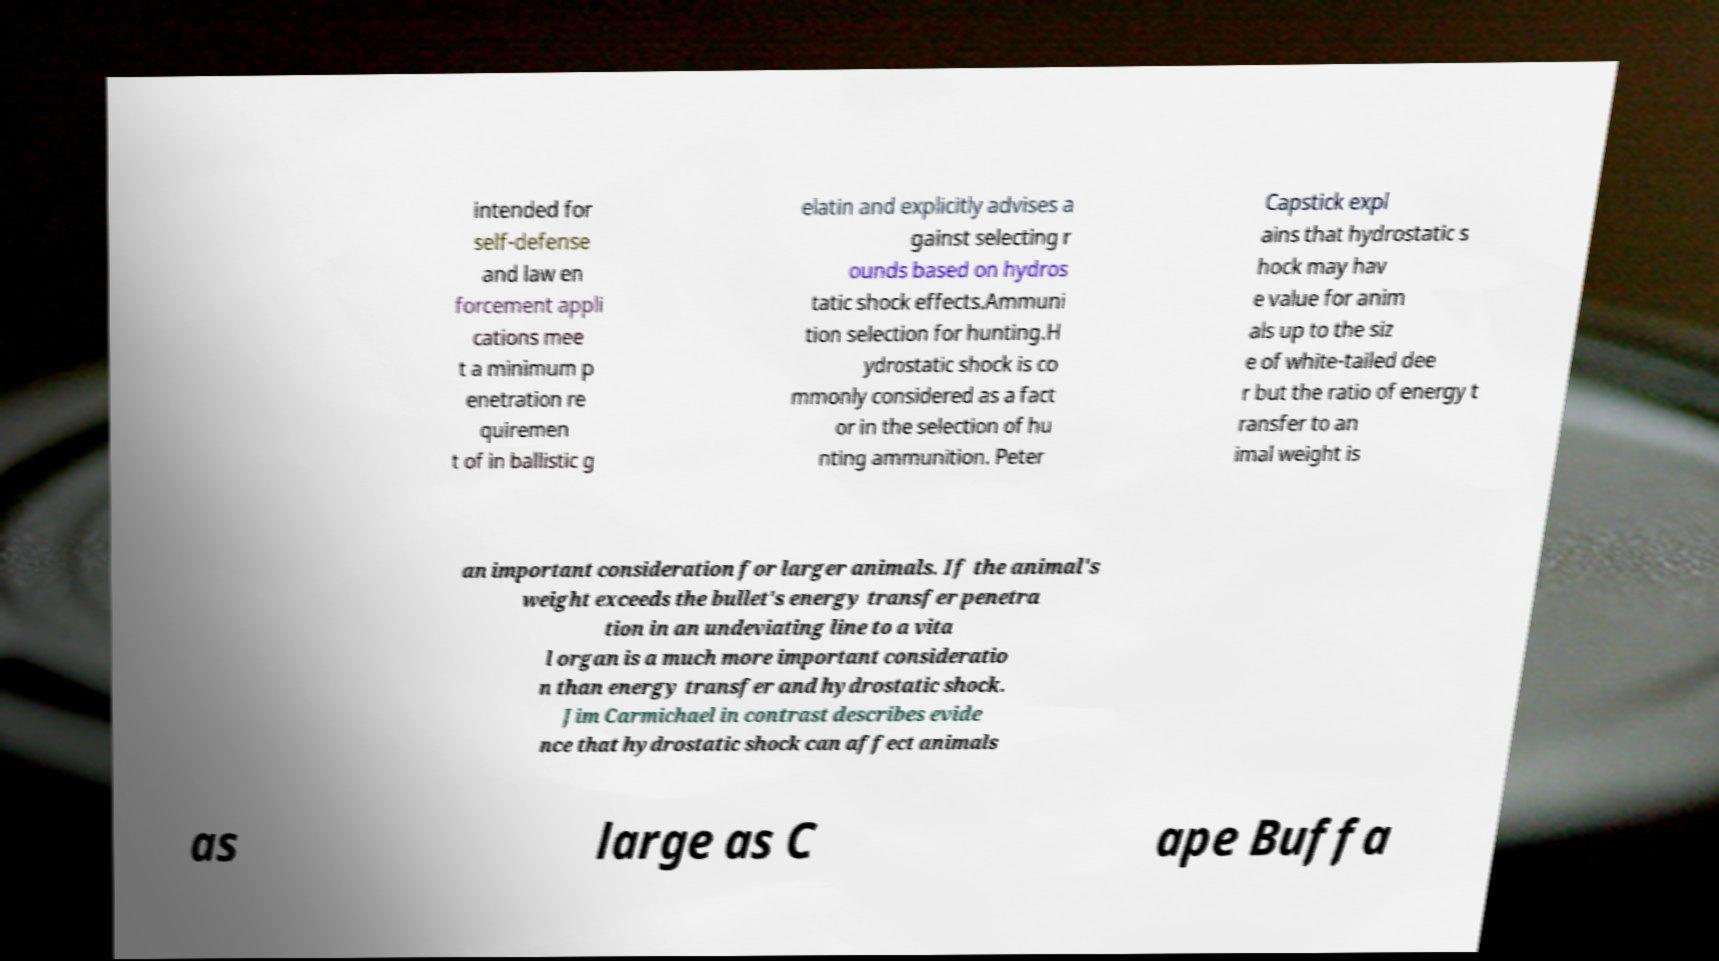Please read and relay the text visible in this image. What does it say? intended for self-defense and law en forcement appli cations mee t a minimum p enetration re quiremen t of in ballistic g elatin and explicitly advises a gainst selecting r ounds based on hydros tatic shock effects.Ammuni tion selection for hunting.H ydrostatic shock is co mmonly considered as a fact or in the selection of hu nting ammunition. Peter Capstick expl ains that hydrostatic s hock may hav e value for anim als up to the siz e of white-tailed dee r but the ratio of energy t ransfer to an imal weight is an important consideration for larger animals. If the animal's weight exceeds the bullet's energy transfer penetra tion in an undeviating line to a vita l organ is a much more important consideratio n than energy transfer and hydrostatic shock. Jim Carmichael in contrast describes evide nce that hydrostatic shock can affect animals as large as C ape Buffa 